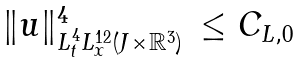<formula> <loc_0><loc_0><loc_500><loc_500>\begin{array} { l l } \| u \| ^ { 4 } _ { L _ { t } ^ { 4 } L _ { x } ^ { 1 2 } ( J \times \mathbb { R } ^ { 3 } ) } & \leq C _ { L , 0 } \end{array}</formula> 